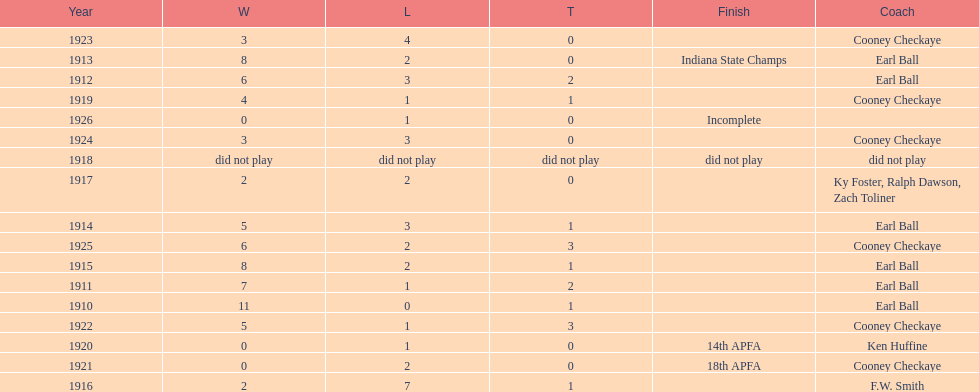How many years did earl ball coach the muncie flyers? 6. 